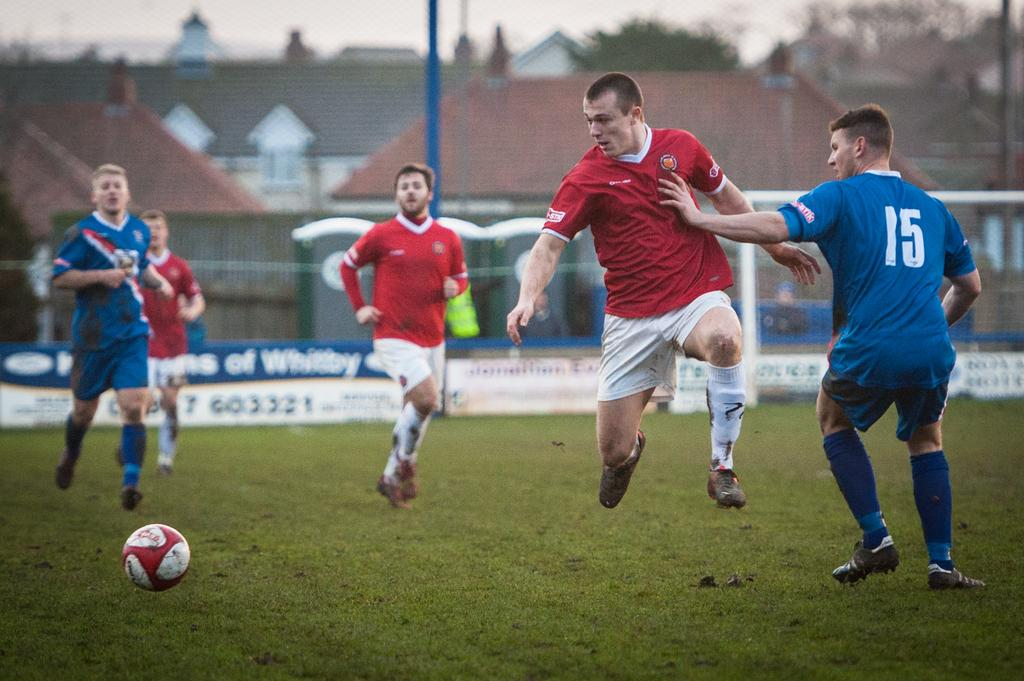<image>
Give a short and clear explanation of the subsequent image. Blue and white Jersey with the number fifteen in white on the back. 